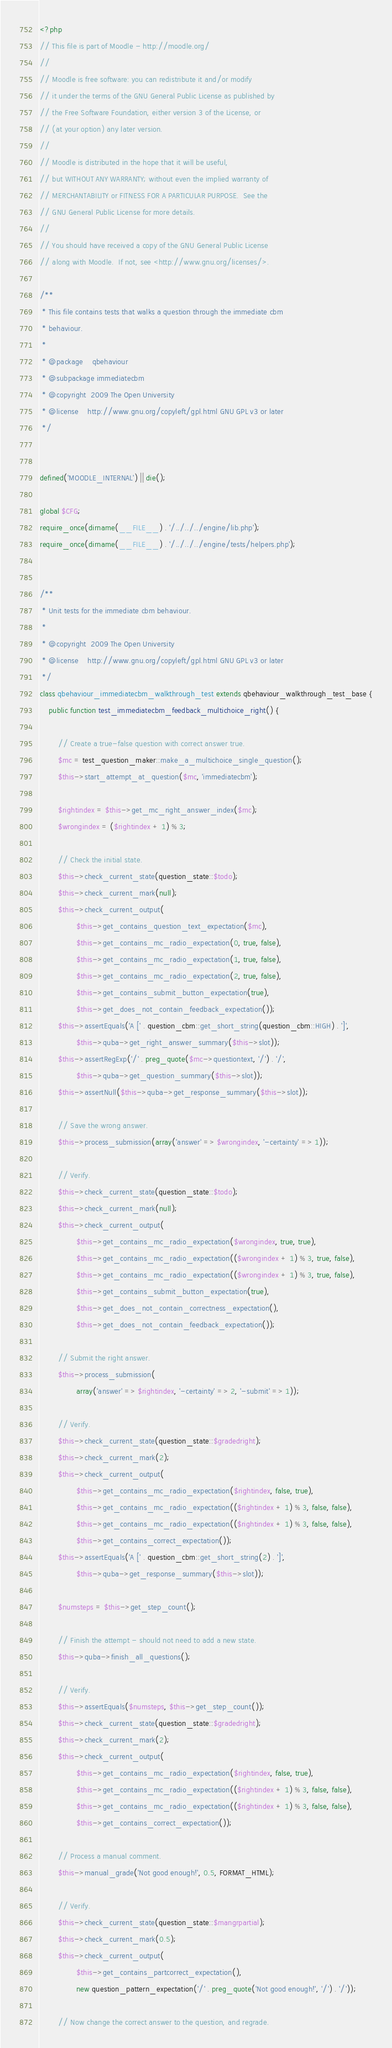Convert code to text. <code><loc_0><loc_0><loc_500><loc_500><_PHP_><?php
// This file is part of Moodle - http://moodle.org/
//
// Moodle is free software: you can redistribute it and/or modify
// it under the terms of the GNU General Public License as published by
// the Free Software Foundation, either version 3 of the License, or
// (at your option) any later version.
//
// Moodle is distributed in the hope that it will be useful,
// but WITHOUT ANY WARRANTY; without even the implied warranty of
// MERCHANTABILITY or FITNESS FOR A PARTICULAR PURPOSE.  See the
// GNU General Public License for more details.
//
// You should have received a copy of the GNU General Public License
// along with Moodle.  If not, see <http://www.gnu.org/licenses/>.

/**
 * This file contains tests that walks a question through the immediate cbm
 * behaviour.
 *
 * @package    qbehaviour
 * @subpackage immediatecbm
 * @copyright  2009 The Open University
 * @license    http://www.gnu.org/copyleft/gpl.html GNU GPL v3 or later
 */


defined('MOODLE_INTERNAL') || die();

global $CFG;
require_once(dirname(__FILE__) . '/../../../engine/lib.php');
require_once(dirname(__FILE__) . '/../../../engine/tests/helpers.php');


/**
 * Unit tests for the immediate cbm behaviour.
 *
 * @copyright  2009 The Open University
 * @license    http://www.gnu.org/copyleft/gpl.html GNU GPL v3 or later
 */
class qbehaviour_immediatecbm_walkthrough_test extends qbehaviour_walkthrough_test_base {
    public function test_immediatecbm_feedback_multichoice_right() {

        // Create a true-false question with correct answer true.
        $mc = test_question_maker::make_a_multichoice_single_question();
        $this->start_attempt_at_question($mc, 'immediatecbm');

        $rightindex = $this->get_mc_right_answer_index($mc);
        $wrongindex = ($rightindex + 1) % 3;

        // Check the initial state.
        $this->check_current_state(question_state::$todo);
        $this->check_current_mark(null);
        $this->check_current_output(
                $this->get_contains_question_text_expectation($mc),
                $this->get_contains_mc_radio_expectation(0, true, false),
                $this->get_contains_mc_radio_expectation(1, true, false),
                $this->get_contains_mc_radio_expectation(2, true, false),
                $this->get_contains_submit_button_expectation(true),
                $this->get_does_not_contain_feedback_expectation());
        $this->assertEquals('A [' . question_cbm::get_short_string(question_cbm::HIGH) . ']',
                $this->quba->get_right_answer_summary($this->slot));
        $this->assertRegExp('/' . preg_quote($mc->questiontext, '/') . '/',
                $this->quba->get_question_summary($this->slot));
        $this->assertNull($this->quba->get_response_summary($this->slot));

        // Save the wrong answer.
        $this->process_submission(array('answer' => $wrongindex, '-certainty' => 1));

        // Verify.
        $this->check_current_state(question_state::$todo);
        $this->check_current_mark(null);
        $this->check_current_output(
                $this->get_contains_mc_radio_expectation($wrongindex, true, true),
                $this->get_contains_mc_radio_expectation(($wrongindex + 1) % 3, true, false),
                $this->get_contains_mc_radio_expectation(($wrongindex + 1) % 3, true, false),
                $this->get_contains_submit_button_expectation(true),
                $this->get_does_not_contain_correctness_expectation(),
                $this->get_does_not_contain_feedback_expectation());

        // Submit the right answer.
        $this->process_submission(
                array('answer' => $rightindex, '-certainty' => 2, '-submit' => 1));

        // Verify.
        $this->check_current_state(question_state::$gradedright);
        $this->check_current_mark(2);
        $this->check_current_output(
                $this->get_contains_mc_radio_expectation($rightindex, false, true),
                $this->get_contains_mc_radio_expectation(($rightindex + 1) % 3, false, false),
                $this->get_contains_mc_radio_expectation(($rightindex + 1) % 3, false, false),
                $this->get_contains_correct_expectation());
        $this->assertEquals('A [' . question_cbm::get_short_string(2) . ']',
                $this->quba->get_response_summary($this->slot));

        $numsteps = $this->get_step_count();

        // Finish the attempt - should not need to add a new state.
        $this->quba->finish_all_questions();

        // Verify.
        $this->assertEquals($numsteps, $this->get_step_count());
        $this->check_current_state(question_state::$gradedright);
        $this->check_current_mark(2);
        $this->check_current_output(
                $this->get_contains_mc_radio_expectation($rightindex, false, true),
                $this->get_contains_mc_radio_expectation(($rightindex + 1) % 3, false, false),
                $this->get_contains_mc_radio_expectation(($rightindex + 1) % 3, false, false),
                $this->get_contains_correct_expectation());

        // Process a manual comment.
        $this->manual_grade('Not good enough!', 0.5, FORMAT_HTML);

        // Verify.
        $this->check_current_state(question_state::$mangrpartial);
        $this->check_current_mark(0.5);
        $this->check_current_output(
                $this->get_contains_partcorrect_expectation(),
                new question_pattern_expectation('/' . preg_quote('Not good enough!', '/') . '/'));

        // Now change the correct answer to the question, and regrade.</code> 